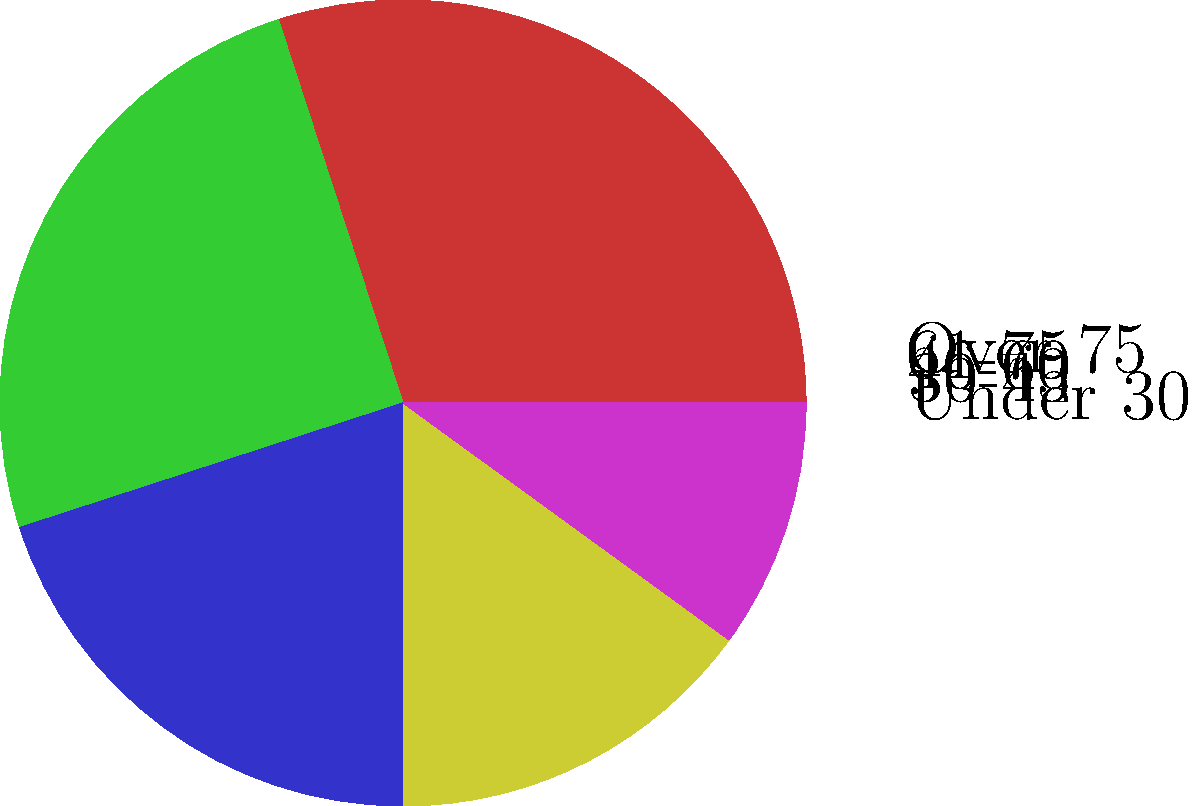As a non-profit organization focused on animal welfare, you've conducted a survey to understand your donor demographics. The pie chart above shows the age distribution of your donors. If you want to increase donations by targeting the two age groups that currently contribute the least, which age groups should you focus on? To answer this question, we need to analyze the pie chart and identify the two smallest slices, which represent the age groups with the lowest contribution to donations. Let's break it down step-by-step:

1. Examine each slice of the pie chart and its corresponding label.
2. Identify the relative sizes of each slice:
   - Under 30: 30%
   - 30-45: 25%
   - 46-60: 20%
   - 61-75: 15%
   - Over 75: 10%
3. Rank the slices from smallest to largest:
   1. Over 75 (10%)
   2. 61-75 (15%)
   3. 46-60 (20%)
   4. 30-45 (25%)
   5. Under 30 (30%)
4. The two smallest slices correspond to the age groups "Over 75" and "61-75".

Therefore, to increase donations by targeting the two age groups that currently contribute the least, the organization should focus on donors aged 61-75 and those over 75 years old.
Answer: 61-75 and Over 75 age groups 